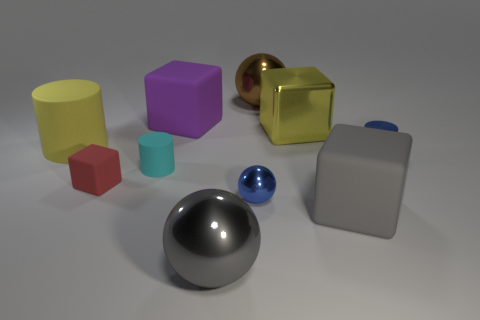How many other objects are the same material as the tiny sphere?
Offer a terse response. 4. How many things are right of the red cube and behind the gray shiny ball?
Provide a short and direct response. 7. What color is the small sphere?
Provide a succinct answer. Blue. There is a large purple thing that is the same shape as the yellow shiny object; what material is it?
Your answer should be compact. Rubber. Does the large matte cylinder have the same color as the metallic cube?
Make the answer very short. Yes. The big metallic object right of the big sphere to the right of the gray metal object is what shape?
Make the answer very short. Cube. There is a big gray object that is the same material as the brown object; what is its shape?
Provide a succinct answer. Sphere. How many other objects are there of the same shape as the brown object?
Your answer should be very brief. 2. Do the blue cylinder that is to the right of the yellow rubber thing and the yellow rubber cylinder have the same size?
Give a very brief answer. No. Are there more big objects in front of the big brown object than tiny red rubber balls?
Make the answer very short. Yes. 